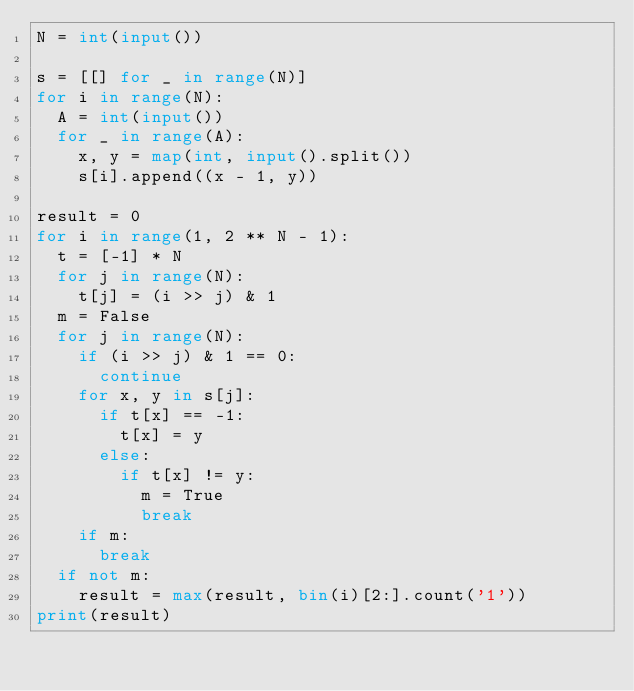Convert code to text. <code><loc_0><loc_0><loc_500><loc_500><_Python_>N = int(input())

s = [[] for _ in range(N)]
for i in range(N):
  A = int(input())
  for _ in range(A):
    x, y = map(int, input().split())
    s[i].append((x - 1, y))

result = 0
for i in range(1, 2 ** N - 1):
  t = [-1] * N
  for j in range(N):
    t[j] = (i >> j) & 1
  m = False
  for j in range(N):
    if (i >> j) & 1 == 0:
      continue
    for x, y in s[j]:
      if t[x] == -1:
        t[x] = y
      else:
        if t[x] != y:
          m = True
          break
    if m:
      break
  if not m:
    result = max(result, bin(i)[2:].count('1'))
print(result)</code> 